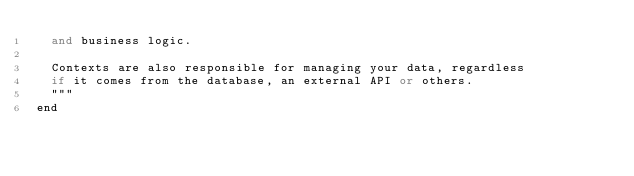Convert code to text. <code><loc_0><loc_0><loc_500><loc_500><_Elixir_>  and business logic.

  Contexts are also responsible for managing your data, regardless
  if it comes from the database, an external API or others.
  """
end
</code> 